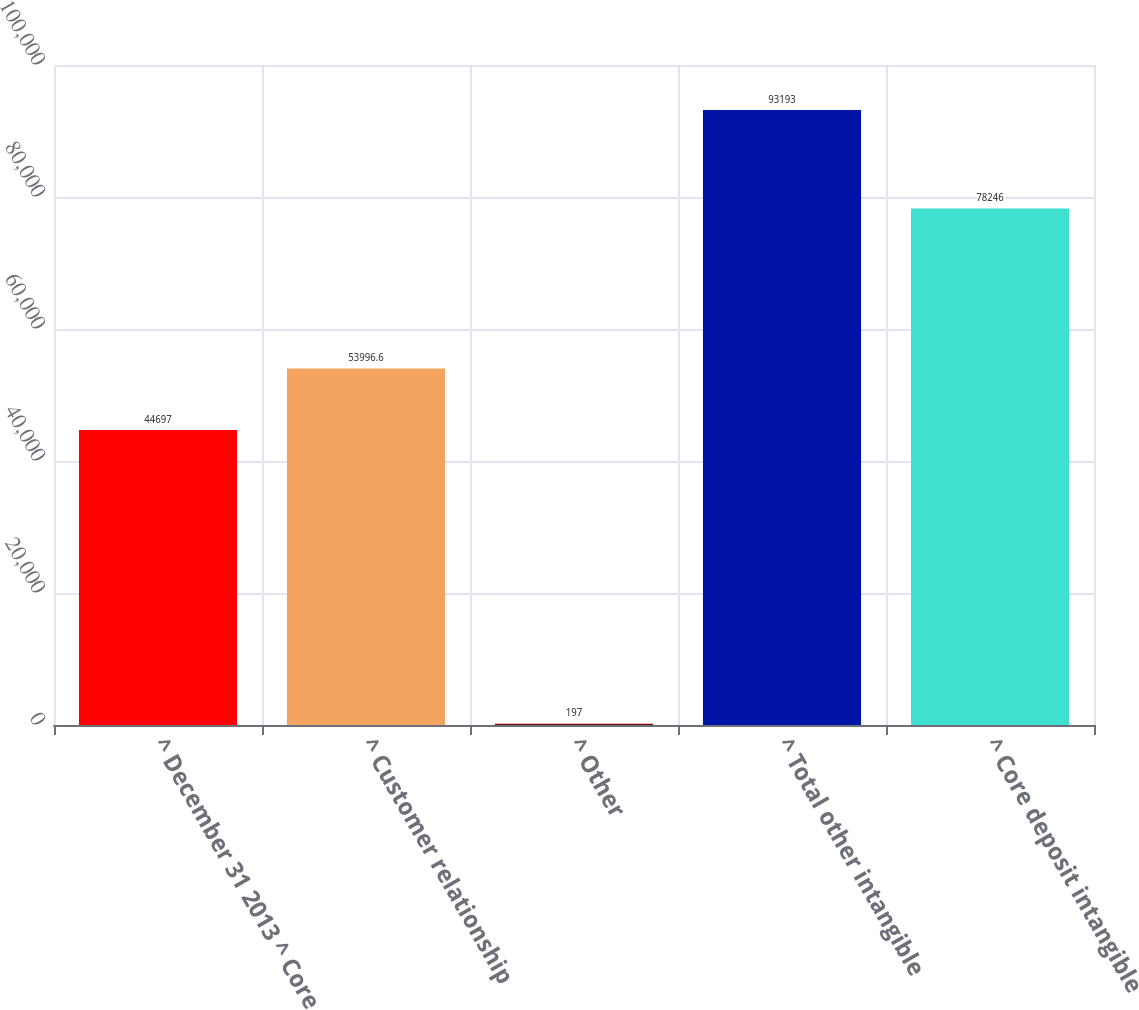<chart> <loc_0><loc_0><loc_500><loc_500><bar_chart><fcel>^ December 31 2013 ^ Core<fcel>^ Customer relationship<fcel>^ Other<fcel>^ Total other intangible<fcel>^ Core deposit intangible<nl><fcel>44697<fcel>53996.6<fcel>197<fcel>93193<fcel>78246<nl></chart> 